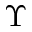Convert formula to latex. <formula><loc_0><loc_0><loc_500><loc_500>\Upsilon</formula> 